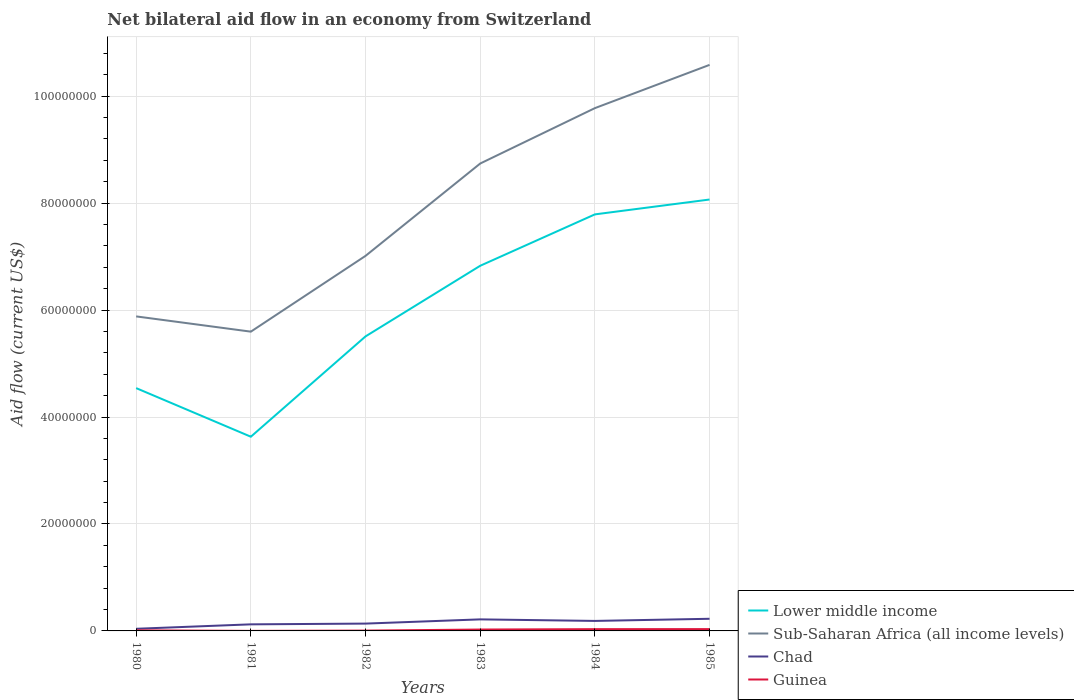How many different coloured lines are there?
Give a very brief answer. 4. Does the line corresponding to Lower middle income intersect with the line corresponding to Guinea?
Ensure brevity in your answer.  No. Is the number of lines equal to the number of legend labels?
Make the answer very short. Yes. Across all years, what is the maximum net bilateral aid flow in Lower middle income?
Offer a very short reply. 3.63e+07. What is the total net bilateral aid flow in Guinea in the graph?
Your response must be concise. -7.00e+04. Is the net bilateral aid flow in Sub-Saharan Africa (all income levels) strictly greater than the net bilateral aid flow in Chad over the years?
Give a very brief answer. No. How many years are there in the graph?
Provide a short and direct response. 6. What is the difference between two consecutive major ticks on the Y-axis?
Your answer should be very brief. 2.00e+07. Does the graph contain grids?
Your answer should be very brief. Yes. What is the title of the graph?
Your answer should be very brief. Net bilateral aid flow in an economy from Switzerland. What is the label or title of the Y-axis?
Your response must be concise. Aid flow (current US$). What is the Aid flow (current US$) of Lower middle income in 1980?
Offer a very short reply. 4.54e+07. What is the Aid flow (current US$) in Sub-Saharan Africa (all income levels) in 1980?
Provide a short and direct response. 5.88e+07. What is the Aid flow (current US$) in Lower middle income in 1981?
Give a very brief answer. 3.63e+07. What is the Aid flow (current US$) of Sub-Saharan Africa (all income levels) in 1981?
Your response must be concise. 5.60e+07. What is the Aid flow (current US$) of Chad in 1981?
Your response must be concise. 1.23e+06. What is the Aid flow (current US$) of Guinea in 1981?
Provide a short and direct response. 10000. What is the Aid flow (current US$) of Lower middle income in 1982?
Keep it short and to the point. 5.51e+07. What is the Aid flow (current US$) of Sub-Saharan Africa (all income levels) in 1982?
Give a very brief answer. 7.01e+07. What is the Aid flow (current US$) of Chad in 1982?
Provide a short and direct response. 1.37e+06. What is the Aid flow (current US$) in Guinea in 1982?
Your response must be concise. 6.00e+04. What is the Aid flow (current US$) of Lower middle income in 1983?
Provide a succinct answer. 6.83e+07. What is the Aid flow (current US$) in Sub-Saharan Africa (all income levels) in 1983?
Provide a succinct answer. 8.74e+07. What is the Aid flow (current US$) of Chad in 1983?
Provide a succinct answer. 2.16e+06. What is the Aid flow (current US$) in Guinea in 1983?
Make the answer very short. 2.60e+05. What is the Aid flow (current US$) of Lower middle income in 1984?
Offer a very short reply. 7.79e+07. What is the Aid flow (current US$) of Sub-Saharan Africa (all income levels) in 1984?
Provide a succinct answer. 9.78e+07. What is the Aid flow (current US$) of Chad in 1984?
Offer a terse response. 1.87e+06. What is the Aid flow (current US$) of Lower middle income in 1985?
Offer a very short reply. 8.07e+07. What is the Aid flow (current US$) of Sub-Saharan Africa (all income levels) in 1985?
Your response must be concise. 1.06e+08. What is the Aid flow (current US$) of Chad in 1985?
Offer a very short reply. 2.27e+06. Across all years, what is the maximum Aid flow (current US$) of Lower middle income?
Provide a succinct answer. 8.07e+07. Across all years, what is the maximum Aid flow (current US$) of Sub-Saharan Africa (all income levels)?
Offer a terse response. 1.06e+08. Across all years, what is the maximum Aid flow (current US$) of Chad?
Give a very brief answer. 2.27e+06. Across all years, what is the minimum Aid flow (current US$) of Lower middle income?
Ensure brevity in your answer.  3.63e+07. Across all years, what is the minimum Aid flow (current US$) in Sub-Saharan Africa (all income levels)?
Ensure brevity in your answer.  5.60e+07. Across all years, what is the minimum Aid flow (current US$) in Chad?
Your response must be concise. 4.00e+05. What is the total Aid flow (current US$) in Lower middle income in the graph?
Your answer should be compact. 3.64e+08. What is the total Aid flow (current US$) of Sub-Saharan Africa (all income levels) in the graph?
Keep it short and to the point. 4.76e+08. What is the total Aid flow (current US$) of Chad in the graph?
Offer a very short reply. 9.30e+06. What is the total Aid flow (current US$) in Guinea in the graph?
Provide a succinct answer. 1.11e+06. What is the difference between the Aid flow (current US$) of Lower middle income in 1980 and that in 1981?
Your answer should be very brief. 9.09e+06. What is the difference between the Aid flow (current US$) in Sub-Saharan Africa (all income levels) in 1980 and that in 1981?
Provide a succinct answer. 2.85e+06. What is the difference between the Aid flow (current US$) in Chad in 1980 and that in 1981?
Provide a succinct answer. -8.30e+05. What is the difference between the Aid flow (current US$) in Lower middle income in 1980 and that in 1982?
Your answer should be very brief. -9.67e+06. What is the difference between the Aid flow (current US$) in Sub-Saharan Africa (all income levels) in 1980 and that in 1982?
Ensure brevity in your answer.  -1.13e+07. What is the difference between the Aid flow (current US$) of Chad in 1980 and that in 1982?
Offer a terse response. -9.70e+05. What is the difference between the Aid flow (current US$) in Lower middle income in 1980 and that in 1983?
Ensure brevity in your answer.  -2.29e+07. What is the difference between the Aid flow (current US$) of Sub-Saharan Africa (all income levels) in 1980 and that in 1983?
Provide a succinct answer. -2.86e+07. What is the difference between the Aid flow (current US$) of Chad in 1980 and that in 1983?
Offer a terse response. -1.76e+06. What is the difference between the Aid flow (current US$) of Guinea in 1980 and that in 1983?
Your response must be concise. -1.50e+05. What is the difference between the Aid flow (current US$) in Lower middle income in 1980 and that in 1984?
Your response must be concise. -3.25e+07. What is the difference between the Aid flow (current US$) in Sub-Saharan Africa (all income levels) in 1980 and that in 1984?
Give a very brief answer. -3.90e+07. What is the difference between the Aid flow (current US$) of Chad in 1980 and that in 1984?
Your answer should be compact. -1.47e+06. What is the difference between the Aid flow (current US$) in Lower middle income in 1980 and that in 1985?
Keep it short and to the point. -3.53e+07. What is the difference between the Aid flow (current US$) of Sub-Saharan Africa (all income levels) in 1980 and that in 1985?
Provide a succinct answer. -4.70e+07. What is the difference between the Aid flow (current US$) of Chad in 1980 and that in 1985?
Make the answer very short. -1.87e+06. What is the difference between the Aid flow (current US$) of Guinea in 1980 and that in 1985?
Offer a very short reply. -2.30e+05. What is the difference between the Aid flow (current US$) in Lower middle income in 1981 and that in 1982?
Offer a terse response. -1.88e+07. What is the difference between the Aid flow (current US$) in Sub-Saharan Africa (all income levels) in 1981 and that in 1982?
Offer a terse response. -1.42e+07. What is the difference between the Aid flow (current US$) in Chad in 1981 and that in 1982?
Your answer should be very brief. -1.40e+05. What is the difference between the Aid flow (current US$) of Lower middle income in 1981 and that in 1983?
Your response must be concise. -3.20e+07. What is the difference between the Aid flow (current US$) in Sub-Saharan Africa (all income levels) in 1981 and that in 1983?
Give a very brief answer. -3.14e+07. What is the difference between the Aid flow (current US$) in Chad in 1981 and that in 1983?
Ensure brevity in your answer.  -9.30e+05. What is the difference between the Aid flow (current US$) of Guinea in 1981 and that in 1983?
Your answer should be very brief. -2.50e+05. What is the difference between the Aid flow (current US$) of Lower middle income in 1981 and that in 1984?
Your answer should be compact. -4.16e+07. What is the difference between the Aid flow (current US$) in Sub-Saharan Africa (all income levels) in 1981 and that in 1984?
Offer a very short reply. -4.18e+07. What is the difference between the Aid flow (current US$) of Chad in 1981 and that in 1984?
Make the answer very short. -6.40e+05. What is the difference between the Aid flow (current US$) in Guinea in 1981 and that in 1984?
Your response must be concise. -3.20e+05. What is the difference between the Aid flow (current US$) of Lower middle income in 1981 and that in 1985?
Make the answer very short. -4.44e+07. What is the difference between the Aid flow (current US$) in Sub-Saharan Africa (all income levels) in 1981 and that in 1985?
Your answer should be very brief. -4.99e+07. What is the difference between the Aid flow (current US$) of Chad in 1981 and that in 1985?
Provide a succinct answer. -1.04e+06. What is the difference between the Aid flow (current US$) of Guinea in 1981 and that in 1985?
Offer a terse response. -3.30e+05. What is the difference between the Aid flow (current US$) in Lower middle income in 1982 and that in 1983?
Offer a terse response. -1.32e+07. What is the difference between the Aid flow (current US$) of Sub-Saharan Africa (all income levels) in 1982 and that in 1983?
Ensure brevity in your answer.  -1.73e+07. What is the difference between the Aid flow (current US$) of Chad in 1982 and that in 1983?
Your answer should be very brief. -7.90e+05. What is the difference between the Aid flow (current US$) in Lower middle income in 1982 and that in 1984?
Your answer should be very brief. -2.28e+07. What is the difference between the Aid flow (current US$) of Sub-Saharan Africa (all income levels) in 1982 and that in 1984?
Give a very brief answer. -2.76e+07. What is the difference between the Aid flow (current US$) in Chad in 1982 and that in 1984?
Give a very brief answer. -5.00e+05. What is the difference between the Aid flow (current US$) of Lower middle income in 1982 and that in 1985?
Your response must be concise. -2.56e+07. What is the difference between the Aid flow (current US$) in Sub-Saharan Africa (all income levels) in 1982 and that in 1985?
Keep it short and to the point. -3.57e+07. What is the difference between the Aid flow (current US$) of Chad in 1982 and that in 1985?
Your response must be concise. -9.00e+05. What is the difference between the Aid flow (current US$) of Guinea in 1982 and that in 1985?
Keep it short and to the point. -2.80e+05. What is the difference between the Aid flow (current US$) in Lower middle income in 1983 and that in 1984?
Ensure brevity in your answer.  -9.61e+06. What is the difference between the Aid flow (current US$) of Sub-Saharan Africa (all income levels) in 1983 and that in 1984?
Your answer should be compact. -1.04e+07. What is the difference between the Aid flow (current US$) of Chad in 1983 and that in 1984?
Your answer should be compact. 2.90e+05. What is the difference between the Aid flow (current US$) in Guinea in 1983 and that in 1984?
Make the answer very short. -7.00e+04. What is the difference between the Aid flow (current US$) in Lower middle income in 1983 and that in 1985?
Keep it short and to the point. -1.24e+07. What is the difference between the Aid flow (current US$) of Sub-Saharan Africa (all income levels) in 1983 and that in 1985?
Keep it short and to the point. -1.84e+07. What is the difference between the Aid flow (current US$) in Guinea in 1983 and that in 1985?
Your answer should be very brief. -8.00e+04. What is the difference between the Aid flow (current US$) of Lower middle income in 1984 and that in 1985?
Ensure brevity in your answer.  -2.78e+06. What is the difference between the Aid flow (current US$) in Sub-Saharan Africa (all income levels) in 1984 and that in 1985?
Your answer should be compact. -8.09e+06. What is the difference between the Aid flow (current US$) in Chad in 1984 and that in 1985?
Give a very brief answer. -4.00e+05. What is the difference between the Aid flow (current US$) in Guinea in 1984 and that in 1985?
Your answer should be compact. -10000. What is the difference between the Aid flow (current US$) in Lower middle income in 1980 and the Aid flow (current US$) in Sub-Saharan Africa (all income levels) in 1981?
Offer a very short reply. -1.06e+07. What is the difference between the Aid flow (current US$) in Lower middle income in 1980 and the Aid flow (current US$) in Chad in 1981?
Your response must be concise. 4.42e+07. What is the difference between the Aid flow (current US$) in Lower middle income in 1980 and the Aid flow (current US$) in Guinea in 1981?
Your answer should be compact. 4.54e+07. What is the difference between the Aid flow (current US$) of Sub-Saharan Africa (all income levels) in 1980 and the Aid flow (current US$) of Chad in 1981?
Your response must be concise. 5.76e+07. What is the difference between the Aid flow (current US$) in Sub-Saharan Africa (all income levels) in 1980 and the Aid flow (current US$) in Guinea in 1981?
Your answer should be compact. 5.88e+07. What is the difference between the Aid flow (current US$) of Chad in 1980 and the Aid flow (current US$) of Guinea in 1981?
Give a very brief answer. 3.90e+05. What is the difference between the Aid flow (current US$) in Lower middle income in 1980 and the Aid flow (current US$) in Sub-Saharan Africa (all income levels) in 1982?
Keep it short and to the point. -2.47e+07. What is the difference between the Aid flow (current US$) of Lower middle income in 1980 and the Aid flow (current US$) of Chad in 1982?
Give a very brief answer. 4.40e+07. What is the difference between the Aid flow (current US$) in Lower middle income in 1980 and the Aid flow (current US$) in Guinea in 1982?
Provide a succinct answer. 4.54e+07. What is the difference between the Aid flow (current US$) of Sub-Saharan Africa (all income levels) in 1980 and the Aid flow (current US$) of Chad in 1982?
Your answer should be compact. 5.74e+07. What is the difference between the Aid flow (current US$) in Sub-Saharan Africa (all income levels) in 1980 and the Aid flow (current US$) in Guinea in 1982?
Your answer should be very brief. 5.88e+07. What is the difference between the Aid flow (current US$) of Chad in 1980 and the Aid flow (current US$) of Guinea in 1982?
Give a very brief answer. 3.40e+05. What is the difference between the Aid flow (current US$) in Lower middle income in 1980 and the Aid flow (current US$) in Sub-Saharan Africa (all income levels) in 1983?
Your answer should be very brief. -4.20e+07. What is the difference between the Aid flow (current US$) of Lower middle income in 1980 and the Aid flow (current US$) of Chad in 1983?
Keep it short and to the point. 4.32e+07. What is the difference between the Aid flow (current US$) in Lower middle income in 1980 and the Aid flow (current US$) in Guinea in 1983?
Your answer should be compact. 4.52e+07. What is the difference between the Aid flow (current US$) in Sub-Saharan Africa (all income levels) in 1980 and the Aid flow (current US$) in Chad in 1983?
Provide a short and direct response. 5.67e+07. What is the difference between the Aid flow (current US$) of Sub-Saharan Africa (all income levels) in 1980 and the Aid flow (current US$) of Guinea in 1983?
Your response must be concise. 5.86e+07. What is the difference between the Aid flow (current US$) in Lower middle income in 1980 and the Aid flow (current US$) in Sub-Saharan Africa (all income levels) in 1984?
Ensure brevity in your answer.  -5.24e+07. What is the difference between the Aid flow (current US$) of Lower middle income in 1980 and the Aid flow (current US$) of Chad in 1984?
Offer a terse response. 4.35e+07. What is the difference between the Aid flow (current US$) in Lower middle income in 1980 and the Aid flow (current US$) in Guinea in 1984?
Your answer should be compact. 4.51e+07. What is the difference between the Aid flow (current US$) in Sub-Saharan Africa (all income levels) in 1980 and the Aid flow (current US$) in Chad in 1984?
Make the answer very short. 5.70e+07. What is the difference between the Aid flow (current US$) in Sub-Saharan Africa (all income levels) in 1980 and the Aid flow (current US$) in Guinea in 1984?
Your answer should be very brief. 5.85e+07. What is the difference between the Aid flow (current US$) in Chad in 1980 and the Aid flow (current US$) in Guinea in 1984?
Give a very brief answer. 7.00e+04. What is the difference between the Aid flow (current US$) in Lower middle income in 1980 and the Aid flow (current US$) in Sub-Saharan Africa (all income levels) in 1985?
Your answer should be compact. -6.04e+07. What is the difference between the Aid flow (current US$) of Lower middle income in 1980 and the Aid flow (current US$) of Chad in 1985?
Ensure brevity in your answer.  4.31e+07. What is the difference between the Aid flow (current US$) of Lower middle income in 1980 and the Aid flow (current US$) of Guinea in 1985?
Offer a terse response. 4.51e+07. What is the difference between the Aid flow (current US$) in Sub-Saharan Africa (all income levels) in 1980 and the Aid flow (current US$) in Chad in 1985?
Provide a short and direct response. 5.66e+07. What is the difference between the Aid flow (current US$) in Sub-Saharan Africa (all income levels) in 1980 and the Aid flow (current US$) in Guinea in 1985?
Make the answer very short. 5.85e+07. What is the difference between the Aid flow (current US$) in Chad in 1980 and the Aid flow (current US$) in Guinea in 1985?
Give a very brief answer. 6.00e+04. What is the difference between the Aid flow (current US$) in Lower middle income in 1981 and the Aid flow (current US$) in Sub-Saharan Africa (all income levels) in 1982?
Your answer should be compact. -3.38e+07. What is the difference between the Aid flow (current US$) of Lower middle income in 1981 and the Aid flow (current US$) of Chad in 1982?
Your answer should be compact. 3.50e+07. What is the difference between the Aid flow (current US$) of Lower middle income in 1981 and the Aid flow (current US$) of Guinea in 1982?
Offer a very short reply. 3.63e+07. What is the difference between the Aid flow (current US$) of Sub-Saharan Africa (all income levels) in 1981 and the Aid flow (current US$) of Chad in 1982?
Ensure brevity in your answer.  5.46e+07. What is the difference between the Aid flow (current US$) in Sub-Saharan Africa (all income levels) in 1981 and the Aid flow (current US$) in Guinea in 1982?
Keep it short and to the point. 5.59e+07. What is the difference between the Aid flow (current US$) in Chad in 1981 and the Aid flow (current US$) in Guinea in 1982?
Keep it short and to the point. 1.17e+06. What is the difference between the Aid flow (current US$) in Lower middle income in 1981 and the Aid flow (current US$) in Sub-Saharan Africa (all income levels) in 1983?
Ensure brevity in your answer.  -5.11e+07. What is the difference between the Aid flow (current US$) in Lower middle income in 1981 and the Aid flow (current US$) in Chad in 1983?
Offer a terse response. 3.42e+07. What is the difference between the Aid flow (current US$) of Lower middle income in 1981 and the Aid flow (current US$) of Guinea in 1983?
Offer a very short reply. 3.61e+07. What is the difference between the Aid flow (current US$) of Sub-Saharan Africa (all income levels) in 1981 and the Aid flow (current US$) of Chad in 1983?
Your answer should be compact. 5.38e+07. What is the difference between the Aid flow (current US$) of Sub-Saharan Africa (all income levels) in 1981 and the Aid flow (current US$) of Guinea in 1983?
Your response must be concise. 5.57e+07. What is the difference between the Aid flow (current US$) of Chad in 1981 and the Aid flow (current US$) of Guinea in 1983?
Your answer should be compact. 9.70e+05. What is the difference between the Aid flow (current US$) in Lower middle income in 1981 and the Aid flow (current US$) in Sub-Saharan Africa (all income levels) in 1984?
Provide a short and direct response. -6.14e+07. What is the difference between the Aid flow (current US$) of Lower middle income in 1981 and the Aid flow (current US$) of Chad in 1984?
Offer a terse response. 3.44e+07. What is the difference between the Aid flow (current US$) in Lower middle income in 1981 and the Aid flow (current US$) in Guinea in 1984?
Give a very brief answer. 3.60e+07. What is the difference between the Aid flow (current US$) in Sub-Saharan Africa (all income levels) in 1981 and the Aid flow (current US$) in Chad in 1984?
Provide a short and direct response. 5.41e+07. What is the difference between the Aid flow (current US$) of Sub-Saharan Africa (all income levels) in 1981 and the Aid flow (current US$) of Guinea in 1984?
Provide a succinct answer. 5.56e+07. What is the difference between the Aid flow (current US$) in Chad in 1981 and the Aid flow (current US$) in Guinea in 1984?
Make the answer very short. 9.00e+05. What is the difference between the Aid flow (current US$) in Lower middle income in 1981 and the Aid flow (current US$) in Sub-Saharan Africa (all income levels) in 1985?
Provide a short and direct response. -6.95e+07. What is the difference between the Aid flow (current US$) in Lower middle income in 1981 and the Aid flow (current US$) in Chad in 1985?
Ensure brevity in your answer.  3.40e+07. What is the difference between the Aid flow (current US$) of Lower middle income in 1981 and the Aid flow (current US$) of Guinea in 1985?
Give a very brief answer. 3.60e+07. What is the difference between the Aid flow (current US$) in Sub-Saharan Africa (all income levels) in 1981 and the Aid flow (current US$) in Chad in 1985?
Give a very brief answer. 5.37e+07. What is the difference between the Aid flow (current US$) of Sub-Saharan Africa (all income levels) in 1981 and the Aid flow (current US$) of Guinea in 1985?
Provide a short and direct response. 5.56e+07. What is the difference between the Aid flow (current US$) in Chad in 1981 and the Aid flow (current US$) in Guinea in 1985?
Your answer should be compact. 8.90e+05. What is the difference between the Aid flow (current US$) of Lower middle income in 1982 and the Aid flow (current US$) of Sub-Saharan Africa (all income levels) in 1983?
Give a very brief answer. -3.23e+07. What is the difference between the Aid flow (current US$) of Lower middle income in 1982 and the Aid flow (current US$) of Chad in 1983?
Ensure brevity in your answer.  5.29e+07. What is the difference between the Aid flow (current US$) in Lower middle income in 1982 and the Aid flow (current US$) in Guinea in 1983?
Keep it short and to the point. 5.48e+07. What is the difference between the Aid flow (current US$) of Sub-Saharan Africa (all income levels) in 1982 and the Aid flow (current US$) of Chad in 1983?
Make the answer very short. 6.80e+07. What is the difference between the Aid flow (current US$) in Sub-Saharan Africa (all income levels) in 1982 and the Aid flow (current US$) in Guinea in 1983?
Provide a short and direct response. 6.99e+07. What is the difference between the Aid flow (current US$) of Chad in 1982 and the Aid flow (current US$) of Guinea in 1983?
Provide a succinct answer. 1.11e+06. What is the difference between the Aid flow (current US$) of Lower middle income in 1982 and the Aid flow (current US$) of Sub-Saharan Africa (all income levels) in 1984?
Your response must be concise. -4.27e+07. What is the difference between the Aid flow (current US$) of Lower middle income in 1982 and the Aid flow (current US$) of Chad in 1984?
Your answer should be compact. 5.32e+07. What is the difference between the Aid flow (current US$) of Lower middle income in 1982 and the Aid flow (current US$) of Guinea in 1984?
Your answer should be very brief. 5.48e+07. What is the difference between the Aid flow (current US$) in Sub-Saharan Africa (all income levels) in 1982 and the Aid flow (current US$) in Chad in 1984?
Your answer should be compact. 6.83e+07. What is the difference between the Aid flow (current US$) of Sub-Saharan Africa (all income levels) in 1982 and the Aid flow (current US$) of Guinea in 1984?
Your response must be concise. 6.98e+07. What is the difference between the Aid flow (current US$) of Chad in 1982 and the Aid flow (current US$) of Guinea in 1984?
Your response must be concise. 1.04e+06. What is the difference between the Aid flow (current US$) in Lower middle income in 1982 and the Aid flow (current US$) in Sub-Saharan Africa (all income levels) in 1985?
Ensure brevity in your answer.  -5.08e+07. What is the difference between the Aid flow (current US$) in Lower middle income in 1982 and the Aid flow (current US$) in Chad in 1985?
Give a very brief answer. 5.28e+07. What is the difference between the Aid flow (current US$) in Lower middle income in 1982 and the Aid flow (current US$) in Guinea in 1985?
Your answer should be very brief. 5.47e+07. What is the difference between the Aid flow (current US$) of Sub-Saharan Africa (all income levels) in 1982 and the Aid flow (current US$) of Chad in 1985?
Ensure brevity in your answer.  6.79e+07. What is the difference between the Aid flow (current US$) of Sub-Saharan Africa (all income levels) in 1982 and the Aid flow (current US$) of Guinea in 1985?
Offer a very short reply. 6.98e+07. What is the difference between the Aid flow (current US$) in Chad in 1982 and the Aid flow (current US$) in Guinea in 1985?
Make the answer very short. 1.03e+06. What is the difference between the Aid flow (current US$) in Lower middle income in 1983 and the Aid flow (current US$) in Sub-Saharan Africa (all income levels) in 1984?
Make the answer very short. -2.95e+07. What is the difference between the Aid flow (current US$) of Lower middle income in 1983 and the Aid flow (current US$) of Chad in 1984?
Make the answer very short. 6.64e+07. What is the difference between the Aid flow (current US$) in Lower middle income in 1983 and the Aid flow (current US$) in Guinea in 1984?
Offer a very short reply. 6.80e+07. What is the difference between the Aid flow (current US$) of Sub-Saharan Africa (all income levels) in 1983 and the Aid flow (current US$) of Chad in 1984?
Offer a very short reply. 8.55e+07. What is the difference between the Aid flow (current US$) of Sub-Saharan Africa (all income levels) in 1983 and the Aid flow (current US$) of Guinea in 1984?
Provide a short and direct response. 8.71e+07. What is the difference between the Aid flow (current US$) in Chad in 1983 and the Aid flow (current US$) in Guinea in 1984?
Offer a very short reply. 1.83e+06. What is the difference between the Aid flow (current US$) in Lower middle income in 1983 and the Aid flow (current US$) in Sub-Saharan Africa (all income levels) in 1985?
Make the answer very short. -3.76e+07. What is the difference between the Aid flow (current US$) in Lower middle income in 1983 and the Aid flow (current US$) in Chad in 1985?
Your answer should be compact. 6.60e+07. What is the difference between the Aid flow (current US$) in Lower middle income in 1983 and the Aid flow (current US$) in Guinea in 1985?
Offer a terse response. 6.80e+07. What is the difference between the Aid flow (current US$) in Sub-Saharan Africa (all income levels) in 1983 and the Aid flow (current US$) in Chad in 1985?
Ensure brevity in your answer.  8.51e+07. What is the difference between the Aid flow (current US$) of Sub-Saharan Africa (all income levels) in 1983 and the Aid flow (current US$) of Guinea in 1985?
Offer a terse response. 8.71e+07. What is the difference between the Aid flow (current US$) in Chad in 1983 and the Aid flow (current US$) in Guinea in 1985?
Offer a terse response. 1.82e+06. What is the difference between the Aid flow (current US$) of Lower middle income in 1984 and the Aid flow (current US$) of Sub-Saharan Africa (all income levels) in 1985?
Ensure brevity in your answer.  -2.80e+07. What is the difference between the Aid flow (current US$) in Lower middle income in 1984 and the Aid flow (current US$) in Chad in 1985?
Offer a terse response. 7.56e+07. What is the difference between the Aid flow (current US$) of Lower middle income in 1984 and the Aid flow (current US$) of Guinea in 1985?
Offer a very short reply. 7.76e+07. What is the difference between the Aid flow (current US$) of Sub-Saharan Africa (all income levels) in 1984 and the Aid flow (current US$) of Chad in 1985?
Offer a very short reply. 9.55e+07. What is the difference between the Aid flow (current US$) in Sub-Saharan Africa (all income levels) in 1984 and the Aid flow (current US$) in Guinea in 1985?
Your answer should be very brief. 9.74e+07. What is the difference between the Aid flow (current US$) of Chad in 1984 and the Aid flow (current US$) of Guinea in 1985?
Your answer should be compact. 1.53e+06. What is the average Aid flow (current US$) of Lower middle income per year?
Your response must be concise. 6.06e+07. What is the average Aid flow (current US$) in Sub-Saharan Africa (all income levels) per year?
Ensure brevity in your answer.  7.93e+07. What is the average Aid flow (current US$) in Chad per year?
Your response must be concise. 1.55e+06. What is the average Aid flow (current US$) of Guinea per year?
Your response must be concise. 1.85e+05. In the year 1980, what is the difference between the Aid flow (current US$) in Lower middle income and Aid flow (current US$) in Sub-Saharan Africa (all income levels)?
Make the answer very short. -1.34e+07. In the year 1980, what is the difference between the Aid flow (current US$) in Lower middle income and Aid flow (current US$) in Chad?
Keep it short and to the point. 4.50e+07. In the year 1980, what is the difference between the Aid flow (current US$) in Lower middle income and Aid flow (current US$) in Guinea?
Provide a succinct answer. 4.53e+07. In the year 1980, what is the difference between the Aid flow (current US$) in Sub-Saharan Africa (all income levels) and Aid flow (current US$) in Chad?
Your response must be concise. 5.84e+07. In the year 1980, what is the difference between the Aid flow (current US$) of Sub-Saharan Africa (all income levels) and Aid flow (current US$) of Guinea?
Your response must be concise. 5.87e+07. In the year 1980, what is the difference between the Aid flow (current US$) in Chad and Aid flow (current US$) in Guinea?
Provide a short and direct response. 2.90e+05. In the year 1981, what is the difference between the Aid flow (current US$) of Lower middle income and Aid flow (current US$) of Sub-Saharan Africa (all income levels)?
Give a very brief answer. -1.96e+07. In the year 1981, what is the difference between the Aid flow (current US$) of Lower middle income and Aid flow (current US$) of Chad?
Your answer should be compact. 3.51e+07. In the year 1981, what is the difference between the Aid flow (current US$) in Lower middle income and Aid flow (current US$) in Guinea?
Provide a succinct answer. 3.63e+07. In the year 1981, what is the difference between the Aid flow (current US$) of Sub-Saharan Africa (all income levels) and Aid flow (current US$) of Chad?
Keep it short and to the point. 5.47e+07. In the year 1981, what is the difference between the Aid flow (current US$) in Sub-Saharan Africa (all income levels) and Aid flow (current US$) in Guinea?
Give a very brief answer. 5.60e+07. In the year 1981, what is the difference between the Aid flow (current US$) in Chad and Aid flow (current US$) in Guinea?
Make the answer very short. 1.22e+06. In the year 1982, what is the difference between the Aid flow (current US$) of Lower middle income and Aid flow (current US$) of Sub-Saharan Africa (all income levels)?
Offer a terse response. -1.51e+07. In the year 1982, what is the difference between the Aid flow (current US$) in Lower middle income and Aid flow (current US$) in Chad?
Your answer should be very brief. 5.37e+07. In the year 1982, what is the difference between the Aid flow (current US$) in Lower middle income and Aid flow (current US$) in Guinea?
Offer a terse response. 5.50e+07. In the year 1982, what is the difference between the Aid flow (current US$) of Sub-Saharan Africa (all income levels) and Aid flow (current US$) of Chad?
Make the answer very short. 6.88e+07. In the year 1982, what is the difference between the Aid flow (current US$) of Sub-Saharan Africa (all income levels) and Aid flow (current US$) of Guinea?
Offer a terse response. 7.01e+07. In the year 1982, what is the difference between the Aid flow (current US$) in Chad and Aid flow (current US$) in Guinea?
Offer a very short reply. 1.31e+06. In the year 1983, what is the difference between the Aid flow (current US$) of Lower middle income and Aid flow (current US$) of Sub-Saharan Africa (all income levels)?
Your answer should be very brief. -1.91e+07. In the year 1983, what is the difference between the Aid flow (current US$) in Lower middle income and Aid flow (current US$) in Chad?
Make the answer very short. 6.61e+07. In the year 1983, what is the difference between the Aid flow (current US$) of Lower middle income and Aid flow (current US$) of Guinea?
Your answer should be very brief. 6.80e+07. In the year 1983, what is the difference between the Aid flow (current US$) of Sub-Saharan Africa (all income levels) and Aid flow (current US$) of Chad?
Give a very brief answer. 8.52e+07. In the year 1983, what is the difference between the Aid flow (current US$) of Sub-Saharan Africa (all income levels) and Aid flow (current US$) of Guinea?
Give a very brief answer. 8.72e+07. In the year 1983, what is the difference between the Aid flow (current US$) in Chad and Aid flow (current US$) in Guinea?
Your answer should be compact. 1.90e+06. In the year 1984, what is the difference between the Aid flow (current US$) of Lower middle income and Aid flow (current US$) of Sub-Saharan Africa (all income levels)?
Ensure brevity in your answer.  -1.99e+07. In the year 1984, what is the difference between the Aid flow (current US$) of Lower middle income and Aid flow (current US$) of Chad?
Keep it short and to the point. 7.60e+07. In the year 1984, what is the difference between the Aid flow (current US$) in Lower middle income and Aid flow (current US$) in Guinea?
Offer a terse response. 7.76e+07. In the year 1984, what is the difference between the Aid flow (current US$) of Sub-Saharan Africa (all income levels) and Aid flow (current US$) of Chad?
Your answer should be very brief. 9.59e+07. In the year 1984, what is the difference between the Aid flow (current US$) in Sub-Saharan Africa (all income levels) and Aid flow (current US$) in Guinea?
Make the answer very short. 9.74e+07. In the year 1984, what is the difference between the Aid flow (current US$) of Chad and Aid flow (current US$) of Guinea?
Keep it short and to the point. 1.54e+06. In the year 1985, what is the difference between the Aid flow (current US$) in Lower middle income and Aid flow (current US$) in Sub-Saharan Africa (all income levels)?
Your response must be concise. -2.52e+07. In the year 1985, what is the difference between the Aid flow (current US$) in Lower middle income and Aid flow (current US$) in Chad?
Offer a terse response. 7.84e+07. In the year 1985, what is the difference between the Aid flow (current US$) in Lower middle income and Aid flow (current US$) in Guinea?
Your answer should be compact. 8.03e+07. In the year 1985, what is the difference between the Aid flow (current US$) in Sub-Saharan Africa (all income levels) and Aid flow (current US$) in Chad?
Your answer should be very brief. 1.04e+08. In the year 1985, what is the difference between the Aid flow (current US$) in Sub-Saharan Africa (all income levels) and Aid flow (current US$) in Guinea?
Your answer should be very brief. 1.06e+08. In the year 1985, what is the difference between the Aid flow (current US$) of Chad and Aid flow (current US$) of Guinea?
Your answer should be compact. 1.93e+06. What is the ratio of the Aid flow (current US$) in Lower middle income in 1980 to that in 1981?
Your answer should be very brief. 1.25. What is the ratio of the Aid flow (current US$) of Sub-Saharan Africa (all income levels) in 1980 to that in 1981?
Provide a short and direct response. 1.05. What is the ratio of the Aid flow (current US$) in Chad in 1980 to that in 1981?
Offer a very short reply. 0.33. What is the ratio of the Aid flow (current US$) of Guinea in 1980 to that in 1981?
Provide a short and direct response. 11. What is the ratio of the Aid flow (current US$) in Lower middle income in 1980 to that in 1982?
Give a very brief answer. 0.82. What is the ratio of the Aid flow (current US$) in Sub-Saharan Africa (all income levels) in 1980 to that in 1982?
Keep it short and to the point. 0.84. What is the ratio of the Aid flow (current US$) in Chad in 1980 to that in 1982?
Provide a short and direct response. 0.29. What is the ratio of the Aid flow (current US$) in Guinea in 1980 to that in 1982?
Provide a succinct answer. 1.83. What is the ratio of the Aid flow (current US$) in Lower middle income in 1980 to that in 1983?
Your answer should be very brief. 0.67. What is the ratio of the Aid flow (current US$) of Sub-Saharan Africa (all income levels) in 1980 to that in 1983?
Your response must be concise. 0.67. What is the ratio of the Aid flow (current US$) of Chad in 1980 to that in 1983?
Provide a short and direct response. 0.19. What is the ratio of the Aid flow (current US$) of Guinea in 1980 to that in 1983?
Keep it short and to the point. 0.42. What is the ratio of the Aid flow (current US$) in Lower middle income in 1980 to that in 1984?
Give a very brief answer. 0.58. What is the ratio of the Aid flow (current US$) in Sub-Saharan Africa (all income levels) in 1980 to that in 1984?
Your answer should be compact. 0.6. What is the ratio of the Aid flow (current US$) of Chad in 1980 to that in 1984?
Provide a succinct answer. 0.21. What is the ratio of the Aid flow (current US$) in Guinea in 1980 to that in 1984?
Offer a terse response. 0.33. What is the ratio of the Aid flow (current US$) of Lower middle income in 1980 to that in 1985?
Ensure brevity in your answer.  0.56. What is the ratio of the Aid flow (current US$) of Sub-Saharan Africa (all income levels) in 1980 to that in 1985?
Offer a terse response. 0.56. What is the ratio of the Aid flow (current US$) of Chad in 1980 to that in 1985?
Provide a succinct answer. 0.18. What is the ratio of the Aid flow (current US$) of Guinea in 1980 to that in 1985?
Make the answer very short. 0.32. What is the ratio of the Aid flow (current US$) in Lower middle income in 1981 to that in 1982?
Make the answer very short. 0.66. What is the ratio of the Aid flow (current US$) in Sub-Saharan Africa (all income levels) in 1981 to that in 1982?
Provide a succinct answer. 0.8. What is the ratio of the Aid flow (current US$) in Chad in 1981 to that in 1982?
Your response must be concise. 0.9. What is the ratio of the Aid flow (current US$) of Guinea in 1981 to that in 1982?
Your answer should be very brief. 0.17. What is the ratio of the Aid flow (current US$) of Lower middle income in 1981 to that in 1983?
Your answer should be very brief. 0.53. What is the ratio of the Aid flow (current US$) of Sub-Saharan Africa (all income levels) in 1981 to that in 1983?
Offer a very short reply. 0.64. What is the ratio of the Aid flow (current US$) in Chad in 1981 to that in 1983?
Your answer should be very brief. 0.57. What is the ratio of the Aid flow (current US$) in Guinea in 1981 to that in 1983?
Your answer should be compact. 0.04. What is the ratio of the Aid flow (current US$) of Lower middle income in 1981 to that in 1984?
Your answer should be compact. 0.47. What is the ratio of the Aid flow (current US$) of Sub-Saharan Africa (all income levels) in 1981 to that in 1984?
Your response must be concise. 0.57. What is the ratio of the Aid flow (current US$) of Chad in 1981 to that in 1984?
Provide a succinct answer. 0.66. What is the ratio of the Aid flow (current US$) in Guinea in 1981 to that in 1984?
Provide a succinct answer. 0.03. What is the ratio of the Aid flow (current US$) of Lower middle income in 1981 to that in 1985?
Give a very brief answer. 0.45. What is the ratio of the Aid flow (current US$) in Sub-Saharan Africa (all income levels) in 1981 to that in 1985?
Offer a very short reply. 0.53. What is the ratio of the Aid flow (current US$) of Chad in 1981 to that in 1985?
Make the answer very short. 0.54. What is the ratio of the Aid flow (current US$) of Guinea in 1981 to that in 1985?
Your response must be concise. 0.03. What is the ratio of the Aid flow (current US$) in Lower middle income in 1982 to that in 1983?
Make the answer very short. 0.81. What is the ratio of the Aid flow (current US$) of Sub-Saharan Africa (all income levels) in 1982 to that in 1983?
Offer a very short reply. 0.8. What is the ratio of the Aid flow (current US$) of Chad in 1982 to that in 1983?
Keep it short and to the point. 0.63. What is the ratio of the Aid flow (current US$) in Guinea in 1982 to that in 1983?
Offer a terse response. 0.23. What is the ratio of the Aid flow (current US$) of Lower middle income in 1982 to that in 1984?
Keep it short and to the point. 0.71. What is the ratio of the Aid flow (current US$) in Sub-Saharan Africa (all income levels) in 1982 to that in 1984?
Ensure brevity in your answer.  0.72. What is the ratio of the Aid flow (current US$) of Chad in 1982 to that in 1984?
Keep it short and to the point. 0.73. What is the ratio of the Aid flow (current US$) of Guinea in 1982 to that in 1984?
Keep it short and to the point. 0.18. What is the ratio of the Aid flow (current US$) in Lower middle income in 1982 to that in 1985?
Make the answer very short. 0.68. What is the ratio of the Aid flow (current US$) of Sub-Saharan Africa (all income levels) in 1982 to that in 1985?
Provide a succinct answer. 0.66. What is the ratio of the Aid flow (current US$) of Chad in 1982 to that in 1985?
Offer a terse response. 0.6. What is the ratio of the Aid flow (current US$) of Guinea in 1982 to that in 1985?
Offer a terse response. 0.18. What is the ratio of the Aid flow (current US$) of Lower middle income in 1983 to that in 1984?
Offer a very short reply. 0.88. What is the ratio of the Aid flow (current US$) in Sub-Saharan Africa (all income levels) in 1983 to that in 1984?
Offer a terse response. 0.89. What is the ratio of the Aid flow (current US$) in Chad in 1983 to that in 1984?
Offer a terse response. 1.16. What is the ratio of the Aid flow (current US$) of Guinea in 1983 to that in 1984?
Your response must be concise. 0.79. What is the ratio of the Aid flow (current US$) in Lower middle income in 1983 to that in 1985?
Provide a short and direct response. 0.85. What is the ratio of the Aid flow (current US$) of Sub-Saharan Africa (all income levels) in 1983 to that in 1985?
Give a very brief answer. 0.83. What is the ratio of the Aid flow (current US$) in Chad in 1983 to that in 1985?
Provide a short and direct response. 0.95. What is the ratio of the Aid flow (current US$) of Guinea in 1983 to that in 1985?
Offer a very short reply. 0.76. What is the ratio of the Aid flow (current US$) in Lower middle income in 1984 to that in 1985?
Provide a short and direct response. 0.97. What is the ratio of the Aid flow (current US$) of Sub-Saharan Africa (all income levels) in 1984 to that in 1985?
Keep it short and to the point. 0.92. What is the ratio of the Aid flow (current US$) in Chad in 1984 to that in 1985?
Offer a very short reply. 0.82. What is the ratio of the Aid flow (current US$) in Guinea in 1984 to that in 1985?
Provide a succinct answer. 0.97. What is the difference between the highest and the second highest Aid flow (current US$) of Lower middle income?
Your response must be concise. 2.78e+06. What is the difference between the highest and the second highest Aid flow (current US$) in Sub-Saharan Africa (all income levels)?
Your response must be concise. 8.09e+06. What is the difference between the highest and the second highest Aid flow (current US$) of Guinea?
Your answer should be very brief. 10000. What is the difference between the highest and the lowest Aid flow (current US$) in Lower middle income?
Offer a very short reply. 4.44e+07. What is the difference between the highest and the lowest Aid flow (current US$) in Sub-Saharan Africa (all income levels)?
Keep it short and to the point. 4.99e+07. What is the difference between the highest and the lowest Aid flow (current US$) of Chad?
Provide a succinct answer. 1.87e+06. 